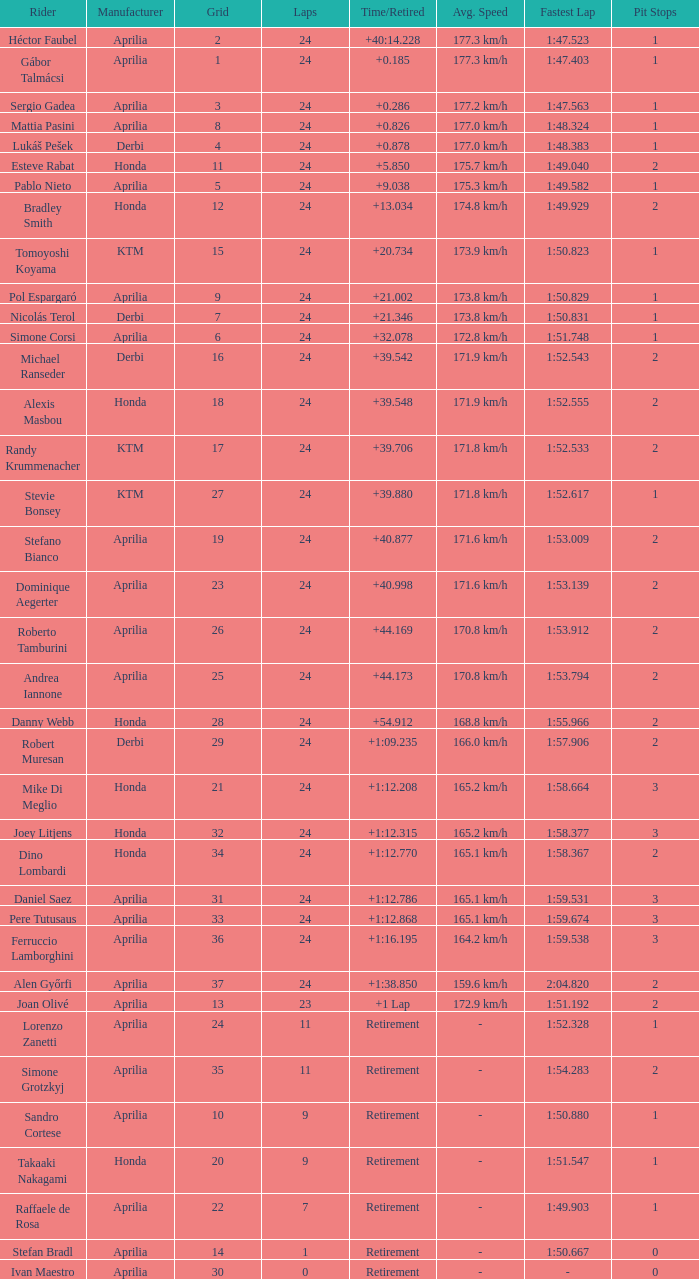Who manufactured the motorcycle that did 24 laps and 9 grids? Aprilia. 